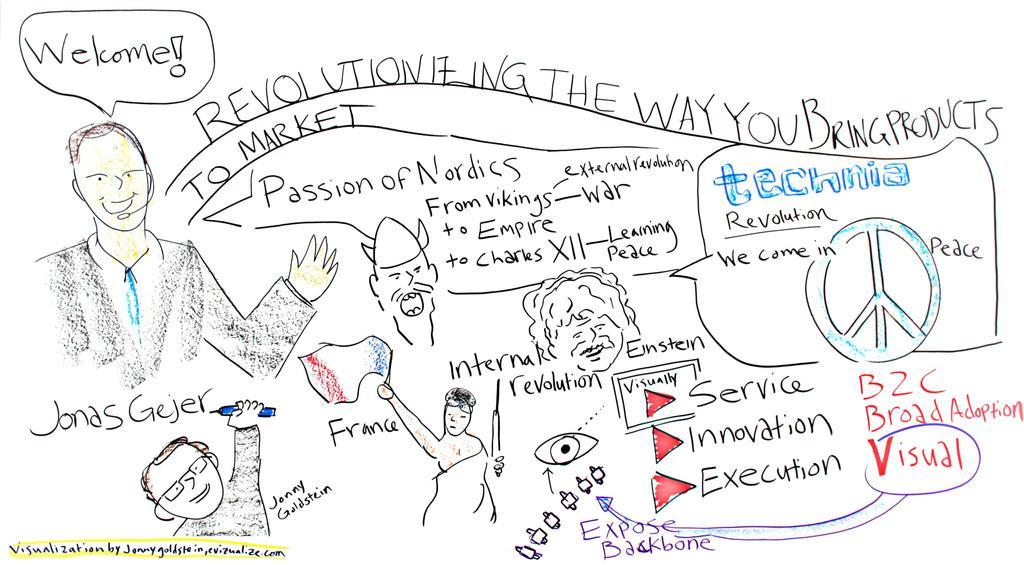Could you give a brief overview of what you see in this image? In this image we can see some pencil sketches, also there are some text. 